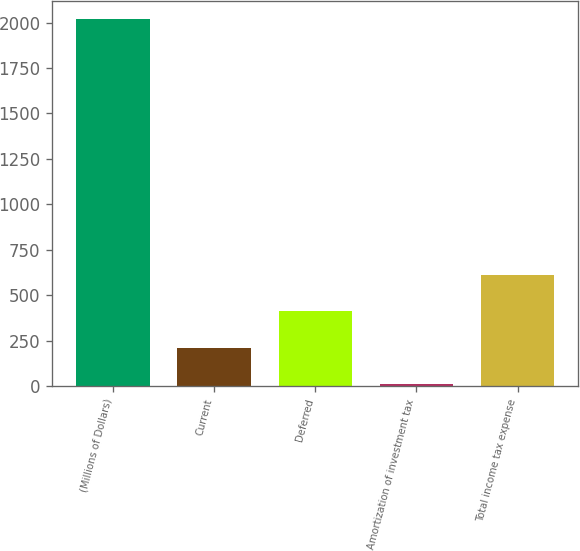Convert chart. <chart><loc_0><loc_0><loc_500><loc_500><bar_chart><fcel>(Millions of Dollars)<fcel>Current<fcel>Deferred<fcel>Amortization of investment tax<fcel>Total income tax expense<nl><fcel>2018<fcel>209.9<fcel>410.8<fcel>9<fcel>611.7<nl></chart> 